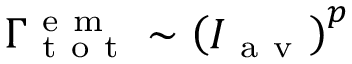<formula> <loc_0><loc_0><loc_500><loc_500>\Gamma _ { t o t } ^ { e m } \sim \left ( I _ { a v } \right ) ^ { p }</formula> 